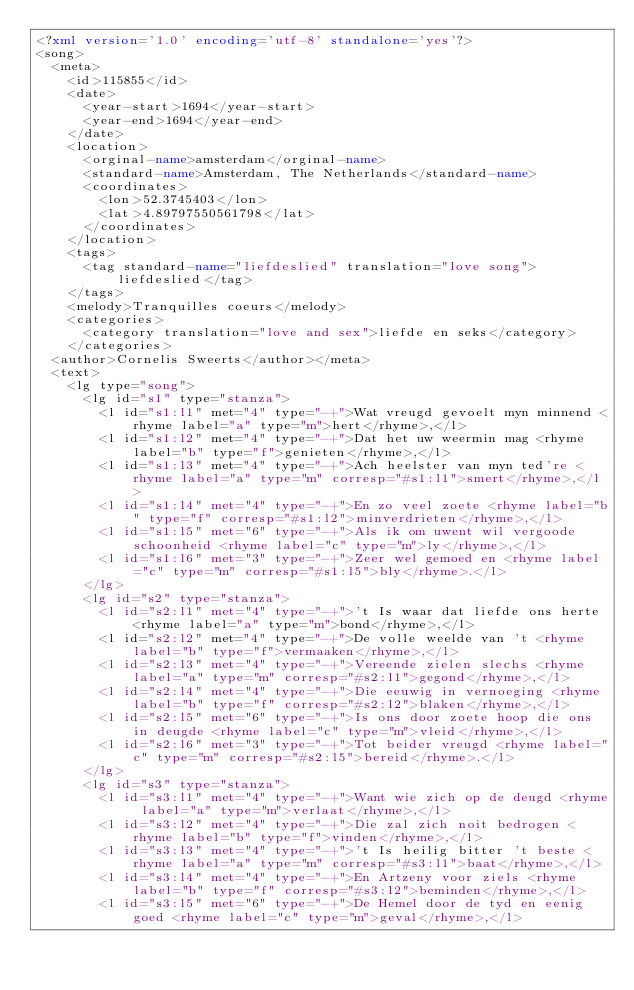<code> <loc_0><loc_0><loc_500><loc_500><_XML_><?xml version='1.0' encoding='utf-8' standalone='yes'?>
<song>
  <meta>
    <id>115855</id>
    <date>
      <year-start>1694</year-start>
      <year-end>1694</year-end>
    </date>
    <location>
      <orginal-name>amsterdam</orginal-name>
      <standard-name>Amsterdam, The Netherlands</standard-name>
      <coordinates>
        <lon>52.3745403</lon>
        <lat>4.89797550561798</lat>
      </coordinates>
    </location>
    <tags>
      <tag standard-name="liefdeslied" translation="love song">liefdeslied</tag>
    </tags>
    <melody>Tranquilles coeurs</melody>
    <categories>
      <category translation="love and sex">liefde en seks</category>
    </categories>
  <author>Cornelis Sweerts</author></meta>
  <text>
    <lg type="song">
      <lg id="s1" type="stanza">
        <l id="s1:l1" met="4" type="-+">Wat vreugd gevoelt myn minnend <rhyme label="a" type="m">hert</rhyme>,</l>
        <l id="s1:l2" met="4" type="-+">Dat het uw weermin mag <rhyme label="b" type="f">genieten</rhyme>,</l>
        <l id="s1:l3" met="4" type="-+">Ach heelster van myn ted're <rhyme label="a" type="m" corresp="#s1:l1">smert</rhyme>,</l>
        <l id="s1:l4" met="4" type="-+">En zo veel zoete <rhyme label="b" type="f" corresp="#s1:l2">minverdrieten</rhyme>,</l>
        <l id="s1:l5" met="6" type="-+">Als ik om uwent wil vergoode schoonheid <rhyme label="c" type="m">ly</rhyme>,</l>
        <l id="s1:l6" met="3" type="-+">Zeer wel gemoed en <rhyme label="c" type="m" corresp="#s1:l5">bly</rhyme>.</l>
      </lg>
      <lg id="s2" type="stanza">
        <l id="s2:l1" met="4" type="-+">'t Is waar dat liefde ons herte <rhyme label="a" type="m">bond</rhyme>,</l>
        <l id="s2:l2" met="4" type="-+">De volle weelde van 't <rhyme label="b" type="f">vermaaken</rhyme>,</l>
        <l id="s2:l3" met="4" type="-+">Vereende zielen slechs <rhyme label="a" type="m" corresp="#s2:l1">gegond</rhyme>,</l>
        <l id="s2:l4" met="4" type="-+">Die eeuwig in vernoeging <rhyme label="b" type="f" corresp="#s2:l2">blaken</rhyme>,</l>
        <l id="s2:l5" met="6" type="-+">Is ons door zoete hoop die ons in deugde <rhyme label="c" type="m">vleid</rhyme>,</l>
        <l id="s2:l6" met="3" type="-+">Tot beider vreugd <rhyme label="c" type="m" corresp="#s2:l5">bereid</rhyme>.</l>
      </lg>
      <lg id="s3" type="stanza">
        <l id="s3:l1" met="4" type="-+">Want wie zich op de deugd <rhyme label="a" type="m">verlaat</rhyme>,</l>
        <l id="s3:l2" met="4" type="-+">Die zal zich noit bedrogen <rhyme label="b" type="f">vinden</rhyme>,</l>
        <l id="s3:l3" met="4" type="-+">'t Is heilig bitter 't beste <rhyme label="a" type="m" corresp="#s3:l1">baat</rhyme>,</l>
        <l id="s3:l4" met="4" type="-+">En Artzeny voor ziels <rhyme label="b" type="f" corresp="#s3:l2">beminden</rhyme>,</l>
        <l id="s3:l5" met="6" type="-+">De Hemel door de tyd en eenig goed <rhyme label="c" type="m">geval</rhyme>,</l></code> 